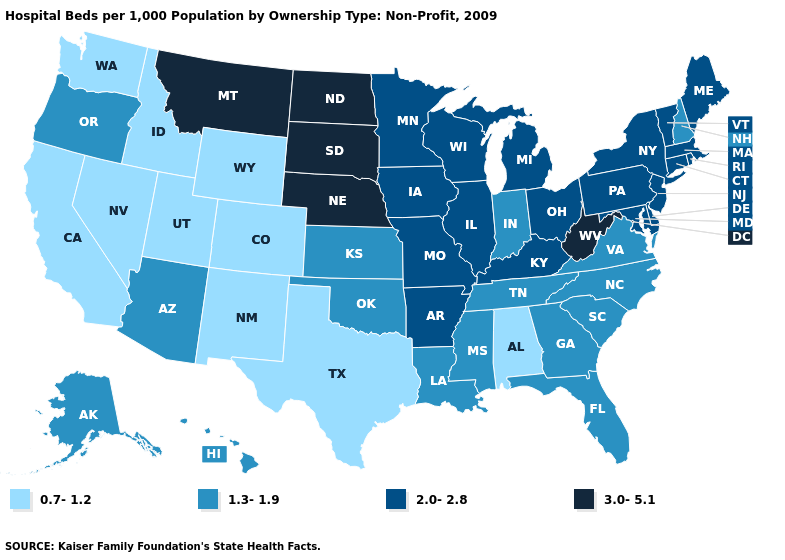Which states hav the highest value in the Northeast?
Give a very brief answer. Connecticut, Maine, Massachusetts, New Jersey, New York, Pennsylvania, Rhode Island, Vermont. Among the states that border Georgia , which have the lowest value?
Quick response, please. Alabama. Does Nebraska have the same value as Kentucky?
Quick response, please. No. Which states have the highest value in the USA?
Write a very short answer. Montana, Nebraska, North Dakota, South Dakota, West Virginia. What is the highest value in states that border Kansas?
Answer briefly. 3.0-5.1. What is the value of Rhode Island?
Keep it brief. 2.0-2.8. Is the legend a continuous bar?
Quick response, please. No. What is the lowest value in states that border Minnesota?
Keep it brief. 2.0-2.8. Does Iowa have the same value as Colorado?
Write a very short answer. No. How many symbols are there in the legend?
Write a very short answer. 4. What is the value of Connecticut?
Give a very brief answer. 2.0-2.8. Name the states that have a value in the range 2.0-2.8?
Concise answer only. Arkansas, Connecticut, Delaware, Illinois, Iowa, Kentucky, Maine, Maryland, Massachusetts, Michigan, Minnesota, Missouri, New Jersey, New York, Ohio, Pennsylvania, Rhode Island, Vermont, Wisconsin. Does Arizona have the highest value in the West?
Write a very short answer. No. Name the states that have a value in the range 0.7-1.2?
Keep it brief. Alabama, California, Colorado, Idaho, Nevada, New Mexico, Texas, Utah, Washington, Wyoming. Name the states that have a value in the range 3.0-5.1?
Keep it brief. Montana, Nebraska, North Dakota, South Dakota, West Virginia. 